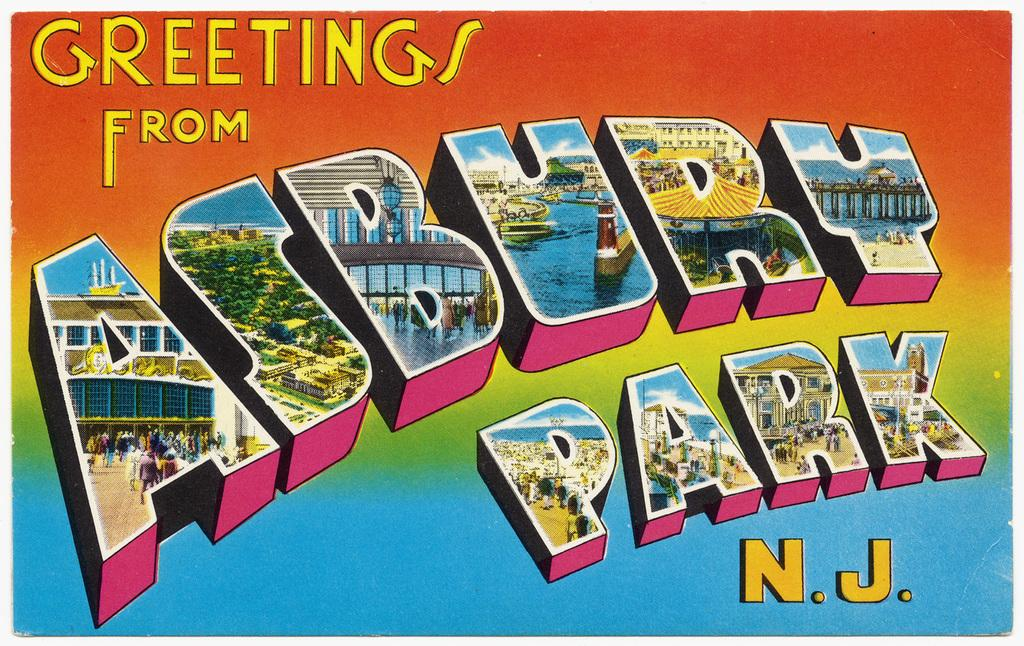<image>
Write a terse but informative summary of the picture. A colorful postcard which sends greeting from Asbury Park, NJ. 